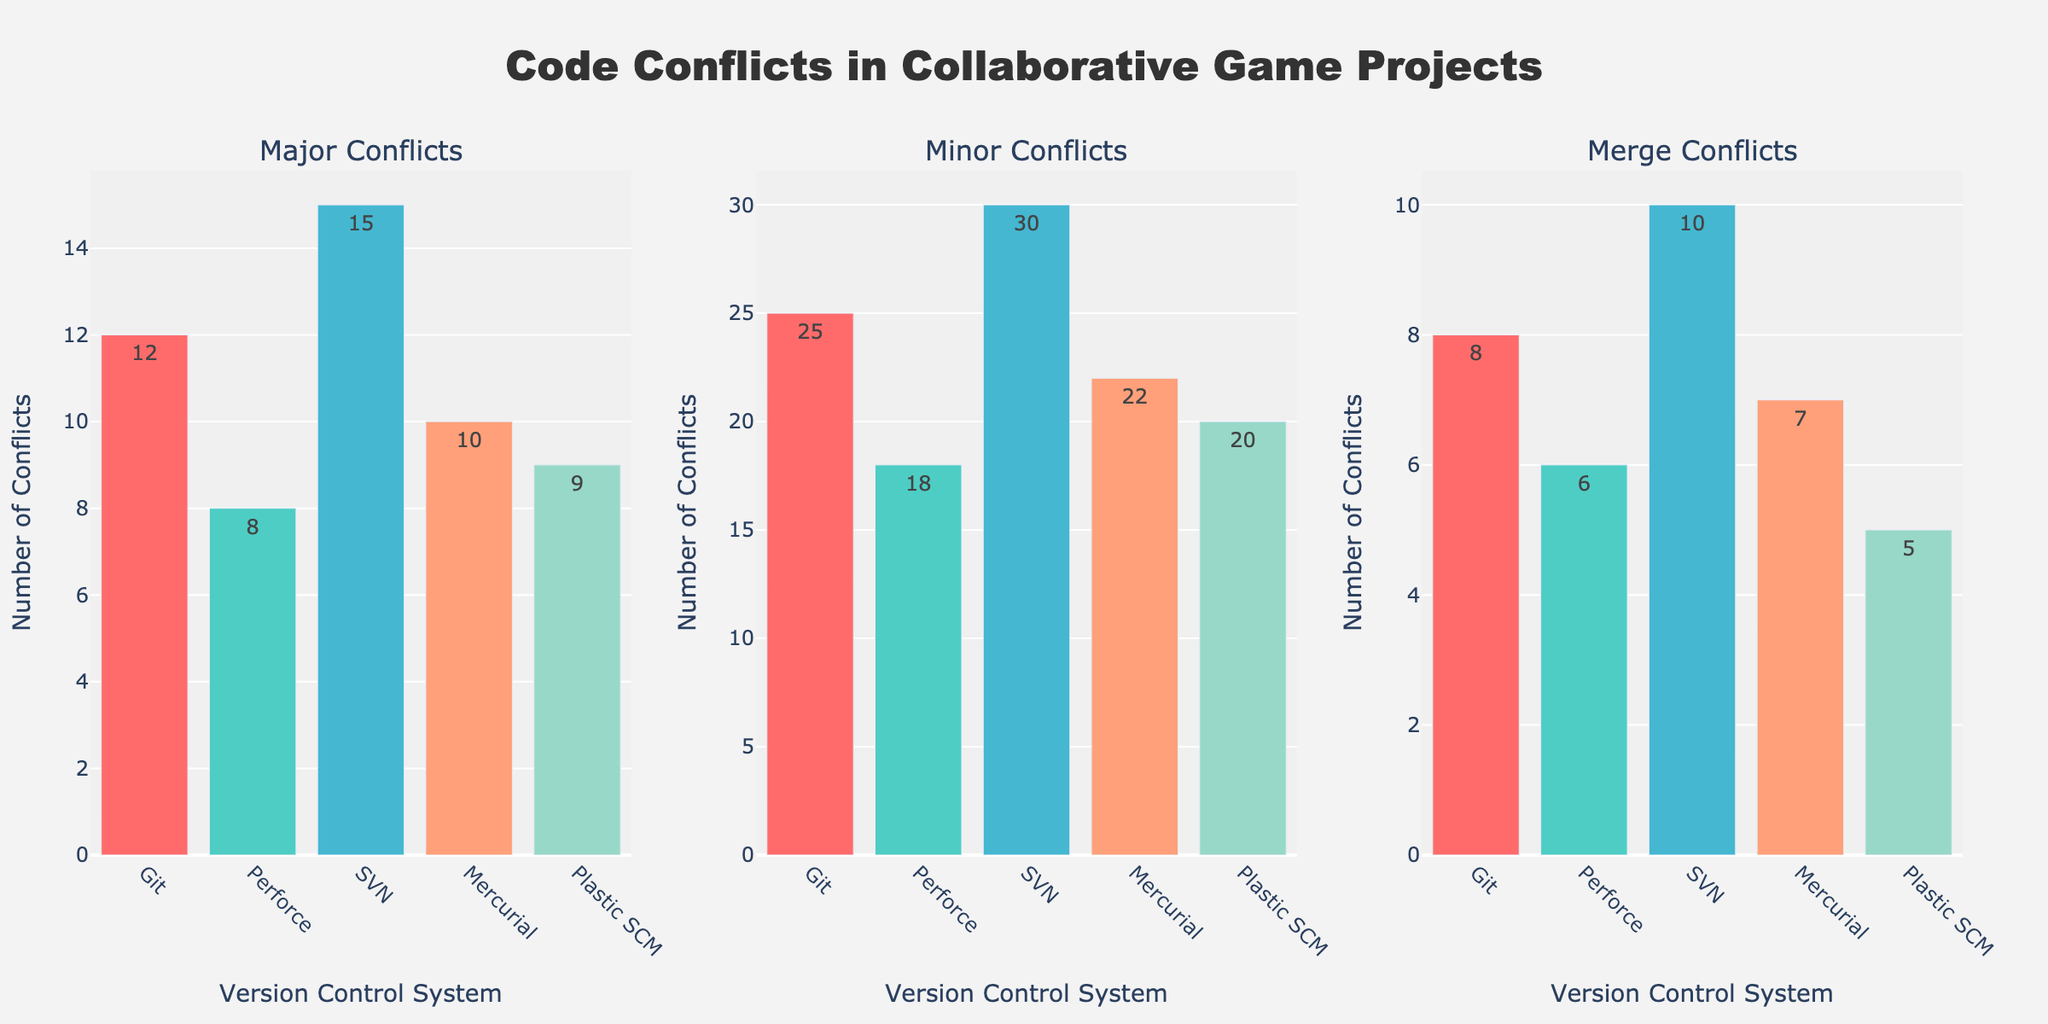What title is used for the plot? The title of the plot is located at the top center and reads "Code Conflicts in Collaborative Game Projects".
Answer: Code Conflicts in Collaborative Game Projects What are the conflict types displayed in the subplots? The subplots are titled based on the conflict types. They are "Major Conflicts", "Minor Conflicts", and "Merge Conflicts".
Answer: Major Conflicts, Minor Conflicts, Merge Conflicts How many version control systems are compared in the plot? Each subplot shows bars for 5 different version control systems: Git, Perforce, SVN, Mercurial, and Plastic SCM.
Answer: 5 What version control system has the highest number of major conflicts? On the "Major Conflicts" subplot, the bar for SVN is the tallest, indicating SVN has the highest number of major conflicts with 15.
Answer: SVN Which version control system has the least minor conflicts? Referring to the "Minor Conflicts" subplot, Plastic SCM has the shortest bar, indicating it has the least minor conflicts with 20.
Answer: Plastic SCM What is the total number of merge conflicts across all version control systems? By summing the values from the "Merge Conflicts" subplot: Git (8) + Perforce (6) + SVN (10) + Mercurial (7) + Plastic SCM (5), the total is 36.
Answer: 36 How does the number of major conflicts in Git compare to Perforce? In the "Major Conflicts" subplot, Git has 12 major conflicts while Perforce has 8, so Git has 4 more major conflicts than Perforce.
Answer: Git has 4 more What is the average number of conflicts in the "Minor Conflicts" category across all systems? Adding the values for minor conflicts: Git (25) + Perforce (18) + SVN (30) + Mercurial (22) + Plastic SCM (20) totals to 115. Dividing this by the 5 systems gives an average of 23.
Answer: 23 Which version control system shows the second highest number of merge conflicts? In the "Merge Conflicts" subplot, SVN has the highest number (10) and Mercurial has the second highest number of merge conflicts with 7.
Answer: Mercurial What is the difference between the number of minor conflicts in Git and SVN? In the "Minor Conflicts" subplot, Git has 25 conflicts while SVN has 30 conflicts. The difference between them is 30 - 25 = 5.
Answer: 5 